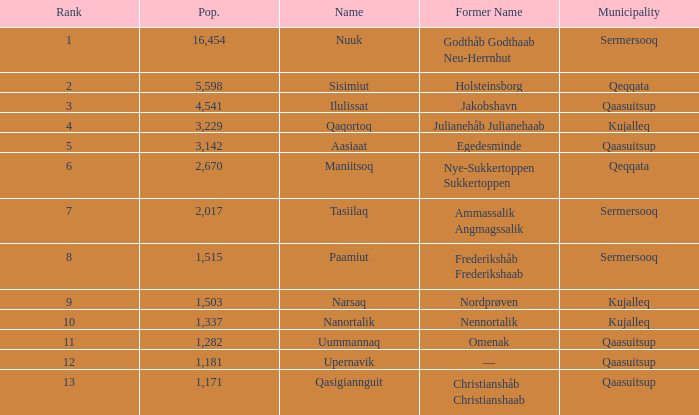Would you be able to parse every entry in this table? {'header': ['Rank', 'Pop.', 'Name', 'Former Name', 'Municipality'], 'rows': [['1', '16,454', 'Nuuk', 'Godthåb Godthaab Neu-Herrnhut', 'Sermersooq'], ['2', '5,598', 'Sisimiut', 'Holsteinsborg', 'Qeqqata'], ['3', '4,541', 'Ilulissat', 'Jakobshavn', 'Qaasuitsup'], ['4', '3,229', 'Qaqortoq', 'Julianehåb Julianehaab', 'Kujalleq'], ['5', '3,142', 'Aasiaat', 'Egedesminde', 'Qaasuitsup'], ['6', '2,670', 'Maniitsoq', 'Nye-Sukkertoppen Sukkertoppen', 'Qeqqata'], ['7', '2,017', 'Tasiilaq', 'Ammassalik Angmagssalik', 'Sermersooq'], ['8', '1,515', 'Paamiut', 'Frederikshåb Frederikshaab', 'Sermersooq'], ['9', '1,503', 'Narsaq', 'Nordprøven', 'Kujalleq'], ['10', '1,337', 'Nanortalik', 'Nennortalik', 'Kujalleq'], ['11', '1,282', 'Uummannaq', 'Omenak', 'Qaasuitsup'], ['12', '1,181', 'Upernavik', '—', 'Qaasuitsup'], ['13', '1,171', 'Qasigiannguit', 'Christianshåb Christianshaab', 'Qaasuitsup']]} Who has a former name of nordprøven? Narsaq. 